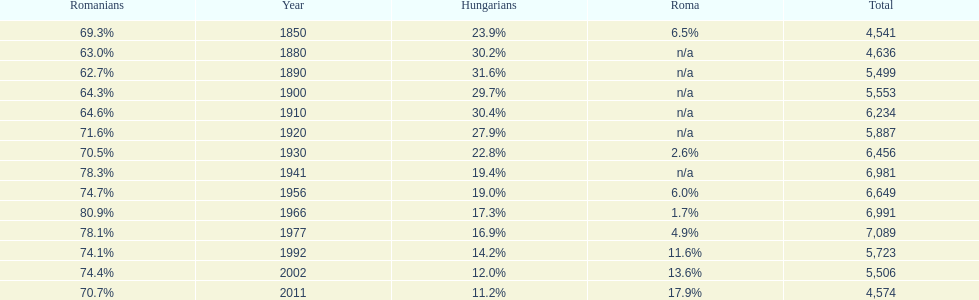Which year had a total of 6,981 and 19.4% hungarians? 1941. 